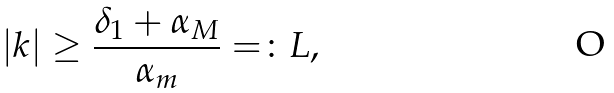Convert formula to latex. <formula><loc_0><loc_0><loc_500><loc_500>| k | \geq \frac { \delta _ { 1 } + \alpha _ { M } } { \alpha _ { m } } = \colon L ,</formula> 